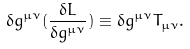Convert formula to latex. <formula><loc_0><loc_0><loc_500><loc_500>\delta g ^ { \mu \nu } ( \frac { \delta L } { \delta g ^ { \mu \nu } } ) \equiv \delta g ^ { \mu \nu } T _ { \mu \nu } .</formula> 